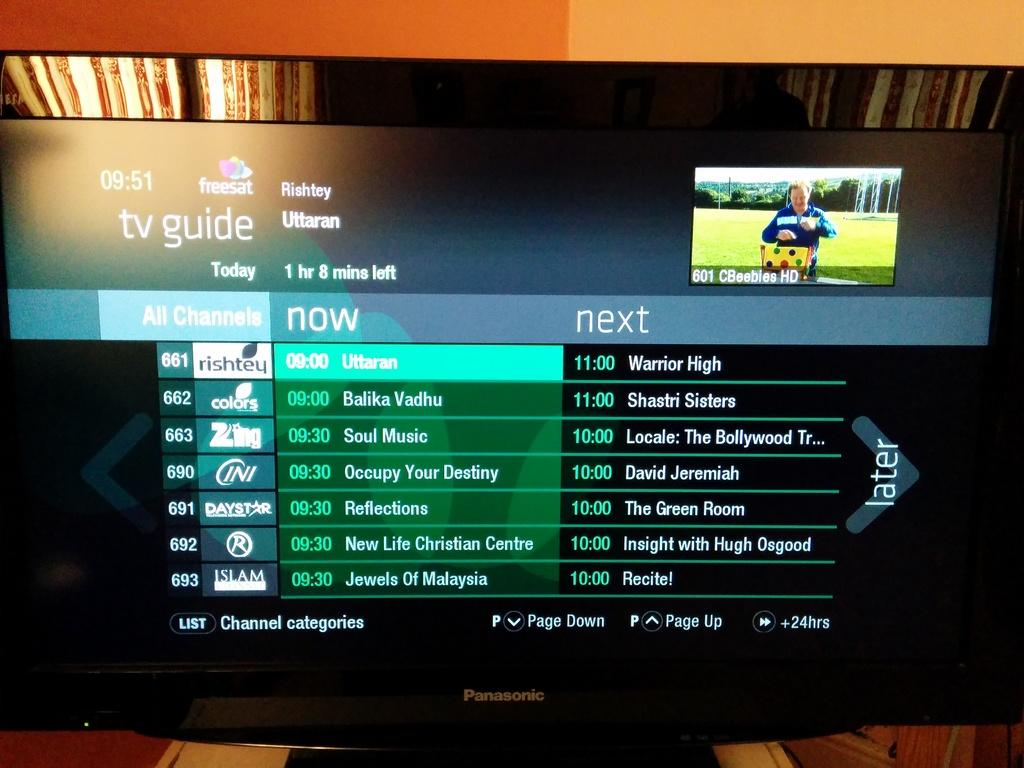<image>
Describe the image concisely. A TV guide is displaying a few different shows at 9, 10 and 11 